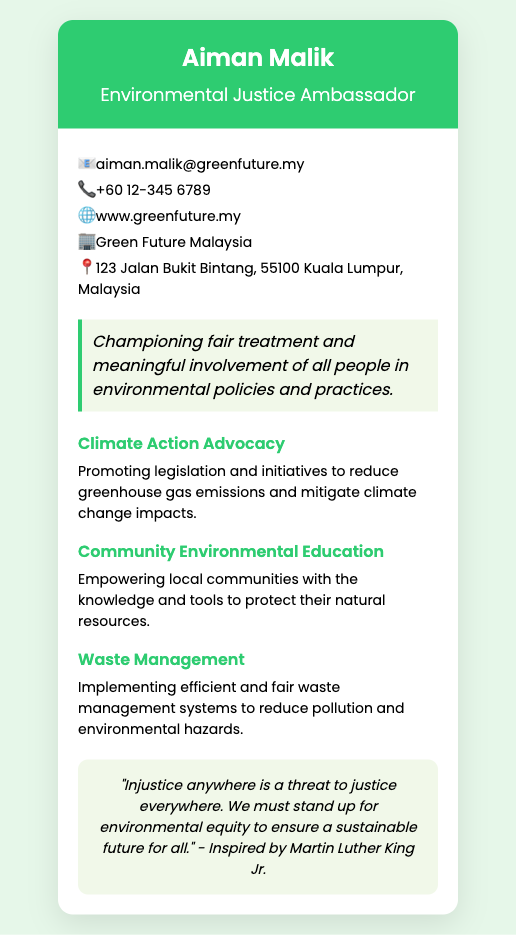what is the name of the ambassador? The ambassador's name is clearly mentioned at the top of the card.
Answer: Aiman Malik what is the email address listed? The email address is provided in the contact information section of the card.
Answer: aiman.malik@greenfuture.my what is the key message on the card? The key message is highlighted in a separate section, emphasizing the ambassador's commitment.
Answer: Championing fair treatment and meaningful involvement of all people in environmental policies and practices which organization is associated with Aiman Malik? The organization is specified in the contact details on the card.
Answer: Green Future Malaysia what is one cause that Aiman Malik advocates for? The causes are listed with headings, indicating areas of focus for advocacy.
Answer: Climate Action Advocacy how can you contact Aiman Malik by phone? The phone number is displayed in the contact information part of the card.
Answer: +60 12-345 6789 what is the address of Green Future Malaysia? The location is stated clearly under the contact information section.
Answer: 123 Jalan Bukit Bintang, 55100 Kuala Lumpur, Malaysia what quote is attributed to Aiman Malik on the card? The quote is shown in a highlighted section, conveying a strong message about justice.
Answer: "Injustice anywhere is a threat to justice everywhere. We must stand up for environmental equity to ensure a sustainable future for all." 